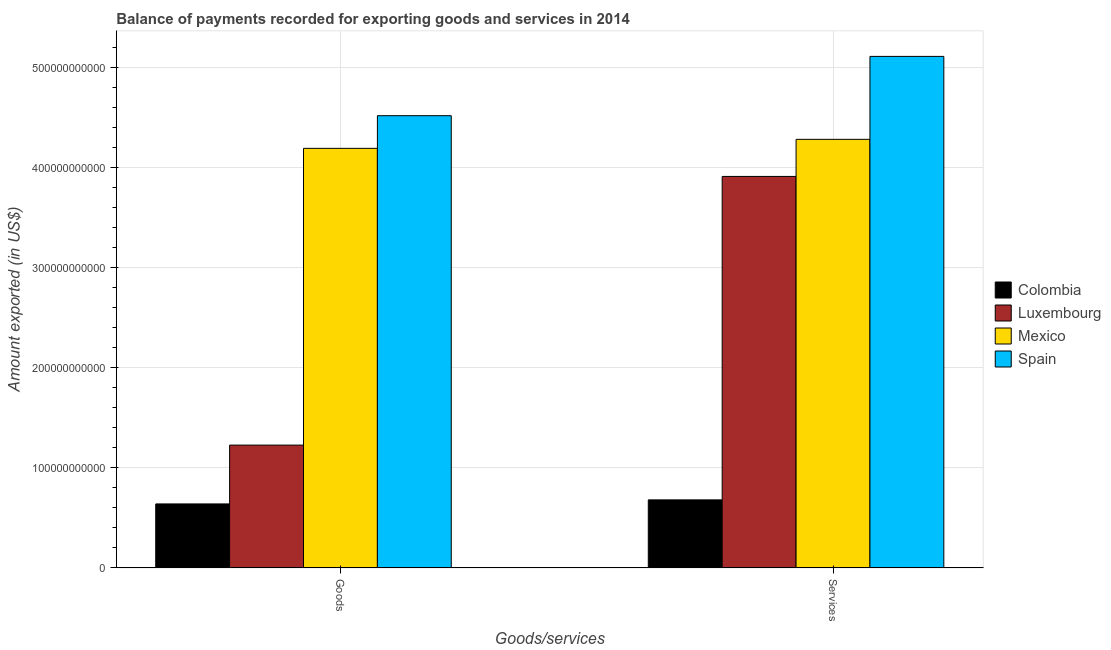How many different coloured bars are there?
Provide a succinct answer. 4. How many groups of bars are there?
Provide a succinct answer. 2. Are the number of bars on each tick of the X-axis equal?
Provide a succinct answer. Yes. How many bars are there on the 2nd tick from the right?
Offer a very short reply. 4. What is the label of the 2nd group of bars from the left?
Your answer should be very brief. Services. What is the amount of goods exported in Colombia?
Make the answer very short. 6.39e+1. Across all countries, what is the maximum amount of services exported?
Provide a short and direct response. 5.11e+11. Across all countries, what is the minimum amount of services exported?
Your answer should be very brief. 6.80e+1. In which country was the amount of goods exported minimum?
Provide a succinct answer. Colombia. What is the total amount of goods exported in the graph?
Provide a succinct answer. 1.06e+12. What is the difference between the amount of services exported in Colombia and that in Spain?
Your answer should be very brief. -4.43e+11. What is the difference between the amount of goods exported in Colombia and the amount of services exported in Mexico?
Provide a short and direct response. -3.64e+11. What is the average amount of services exported per country?
Provide a short and direct response. 3.49e+11. What is the difference between the amount of services exported and amount of goods exported in Luxembourg?
Offer a very short reply. 2.68e+11. In how many countries, is the amount of services exported greater than 20000000000 US$?
Provide a succinct answer. 4. What is the ratio of the amount of services exported in Luxembourg to that in Colombia?
Your response must be concise. 5.75. Is the amount of goods exported in Spain less than that in Colombia?
Provide a succinct answer. No. In how many countries, is the amount of goods exported greater than the average amount of goods exported taken over all countries?
Offer a very short reply. 2. What does the 1st bar from the left in Goods represents?
Provide a short and direct response. Colombia. What does the 3rd bar from the right in Goods represents?
Your answer should be compact. Luxembourg. How many bars are there?
Give a very brief answer. 8. What is the difference between two consecutive major ticks on the Y-axis?
Keep it short and to the point. 1.00e+11. Does the graph contain any zero values?
Provide a short and direct response. No. Does the graph contain grids?
Give a very brief answer. Yes. Where does the legend appear in the graph?
Give a very brief answer. Center right. How are the legend labels stacked?
Provide a succinct answer. Vertical. What is the title of the graph?
Provide a short and direct response. Balance of payments recorded for exporting goods and services in 2014. Does "Sint Maarten (Dutch part)" appear as one of the legend labels in the graph?
Keep it short and to the point. No. What is the label or title of the X-axis?
Ensure brevity in your answer.  Goods/services. What is the label or title of the Y-axis?
Offer a very short reply. Amount exported (in US$). What is the Amount exported (in US$) in Colombia in Goods?
Make the answer very short. 6.39e+1. What is the Amount exported (in US$) in Luxembourg in Goods?
Offer a terse response. 1.23e+11. What is the Amount exported (in US$) of Mexico in Goods?
Keep it short and to the point. 4.19e+11. What is the Amount exported (in US$) of Spain in Goods?
Make the answer very short. 4.52e+11. What is the Amount exported (in US$) in Colombia in Services?
Your answer should be very brief. 6.80e+1. What is the Amount exported (in US$) of Luxembourg in Services?
Your answer should be compact. 3.91e+11. What is the Amount exported (in US$) of Mexico in Services?
Provide a succinct answer. 4.28e+11. What is the Amount exported (in US$) in Spain in Services?
Your answer should be compact. 5.11e+11. Across all Goods/services, what is the maximum Amount exported (in US$) in Colombia?
Provide a short and direct response. 6.80e+1. Across all Goods/services, what is the maximum Amount exported (in US$) of Luxembourg?
Keep it short and to the point. 3.91e+11. Across all Goods/services, what is the maximum Amount exported (in US$) of Mexico?
Keep it short and to the point. 4.28e+11. Across all Goods/services, what is the maximum Amount exported (in US$) of Spain?
Provide a short and direct response. 5.11e+11. Across all Goods/services, what is the minimum Amount exported (in US$) in Colombia?
Provide a succinct answer. 6.39e+1. Across all Goods/services, what is the minimum Amount exported (in US$) of Luxembourg?
Give a very brief answer. 1.23e+11. Across all Goods/services, what is the minimum Amount exported (in US$) of Mexico?
Offer a very short reply. 4.19e+11. Across all Goods/services, what is the minimum Amount exported (in US$) of Spain?
Make the answer very short. 4.52e+11. What is the total Amount exported (in US$) in Colombia in the graph?
Ensure brevity in your answer.  1.32e+11. What is the total Amount exported (in US$) in Luxembourg in the graph?
Make the answer very short. 5.14e+11. What is the total Amount exported (in US$) in Mexico in the graph?
Ensure brevity in your answer.  8.47e+11. What is the total Amount exported (in US$) in Spain in the graph?
Keep it short and to the point. 9.62e+11. What is the difference between the Amount exported (in US$) in Colombia in Goods and that in Services?
Make the answer very short. -4.04e+09. What is the difference between the Amount exported (in US$) of Luxembourg in Goods and that in Services?
Provide a short and direct response. -2.68e+11. What is the difference between the Amount exported (in US$) in Mexico in Goods and that in Services?
Keep it short and to the point. -8.99e+09. What is the difference between the Amount exported (in US$) of Spain in Goods and that in Services?
Give a very brief answer. -5.92e+1. What is the difference between the Amount exported (in US$) in Colombia in Goods and the Amount exported (in US$) in Luxembourg in Services?
Provide a succinct answer. -3.27e+11. What is the difference between the Amount exported (in US$) in Colombia in Goods and the Amount exported (in US$) in Mexico in Services?
Make the answer very short. -3.64e+11. What is the difference between the Amount exported (in US$) of Colombia in Goods and the Amount exported (in US$) of Spain in Services?
Make the answer very short. -4.47e+11. What is the difference between the Amount exported (in US$) of Luxembourg in Goods and the Amount exported (in US$) of Mexico in Services?
Keep it short and to the point. -3.05e+11. What is the difference between the Amount exported (in US$) of Luxembourg in Goods and the Amount exported (in US$) of Spain in Services?
Make the answer very short. -3.88e+11. What is the difference between the Amount exported (in US$) of Mexico in Goods and the Amount exported (in US$) of Spain in Services?
Give a very brief answer. -9.18e+1. What is the average Amount exported (in US$) in Colombia per Goods/services?
Your answer should be very brief. 6.59e+1. What is the average Amount exported (in US$) in Luxembourg per Goods/services?
Make the answer very short. 2.57e+11. What is the average Amount exported (in US$) in Mexico per Goods/services?
Give a very brief answer. 4.23e+11. What is the average Amount exported (in US$) of Spain per Goods/services?
Keep it short and to the point. 4.81e+11. What is the difference between the Amount exported (in US$) in Colombia and Amount exported (in US$) in Luxembourg in Goods?
Provide a short and direct response. -5.87e+1. What is the difference between the Amount exported (in US$) of Colombia and Amount exported (in US$) of Mexico in Goods?
Your answer should be compact. -3.55e+11. What is the difference between the Amount exported (in US$) in Colombia and Amount exported (in US$) in Spain in Goods?
Provide a short and direct response. -3.88e+11. What is the difference between the Amount exported (in US$) of Luxembourg and Amount exported (in US$) of Mexico in Goods?
Ensure brevity in your answer.  -2.96e+11. What is the difference between the Amount exported (in US$) of Luxembourg and Amount exported (in US$) of Spain in Goods?
Offer a terse response. -3.29e+11. What is the difference between the Amount exported (in US$) in Mexico and Amount exported (in US$) in Spain in Goods?
Provide a short and direct response. -3.26e+1. What is the difference between the Amount exported (in US$) in Colombia and Amount exported (in US$) in Luxembourg in Services?
Make the answer very short. -3.23e+11. What is the difference between the Amount exported (in US$) of Colombia and Amount exported (in US$) of Mexico in Services?
Offer a terse response. -3.60e+11. What is the difference between the Amount exported (in US$) in Colombia and Amount exported (in US$) in Spain in Services?
Your answer should be compact. -4.43e+11. What is the difference between the Amount exported (in US$) of Luxembourg and Amount exported (in US$) of Mexico in Services?
Offer a very short reply. -3.70e+1. What is the difference between the Amount exported (in US$) in Luxembourg and Amount exported (in US$) in Spain in Services?
Give a very brief answer. -1.20e+11. What is the difference between the Amount exported (in US$) in Mexico and Amount exported (in US$) in Spain in Services?
Give a very brief answer. -8.28e+1. What is the ratio of the Amount exported (in US$) in Colombia in Goods to that in Services?
Keep it short and to the point. 0.94. What is the ratio of the Amount exported (in US$) of Luxembourg in Goods to that in Services?
Provide a succinct answer. 0.31. What is the ratio of the Amount exported (in US$) of Mexico in Goods to that in Services?
Your response must be concise. 0.98. What is the ratio of the Amount exported (in US$) of Spain in Goods to that in Services?
Make the answer very short. 0.88. What is the difference between the highest and the second highest Amount exported (in US$) in Colombia?
Keep it short and to the point. 4.04e+09. What is the difference between the highest and the second highest Amount exported (in US$) in Luxembourg?
Offer a terse response. 2.68e+11. What is the difference between the highest and the second highest Amount exported (in US$) of Mexico?
Make the answer very short. 8.99e+09. What is the difference between the highest and the second highest Amount exported (in US$) of Spain?
Your answer should be compact. 5.92e+1. What is the difference between the highest and the lowest Amount exported (in US$) in Colombia?
Your response must be concise. 4.04e+09. What is the difference between the highest and the lowest Amount exported (in US$) of Luxembourg?
Give a very brief answer. 2.68e+11. What is the difference between the highest and the lowest Amount exported (in US$) of Mexico?
Your response must be concise. 8.99e+09. What is the difference between the highest and the lowest Amount exported (in US$) in Spain?
Offer a very short reply. 5.92e+1. 